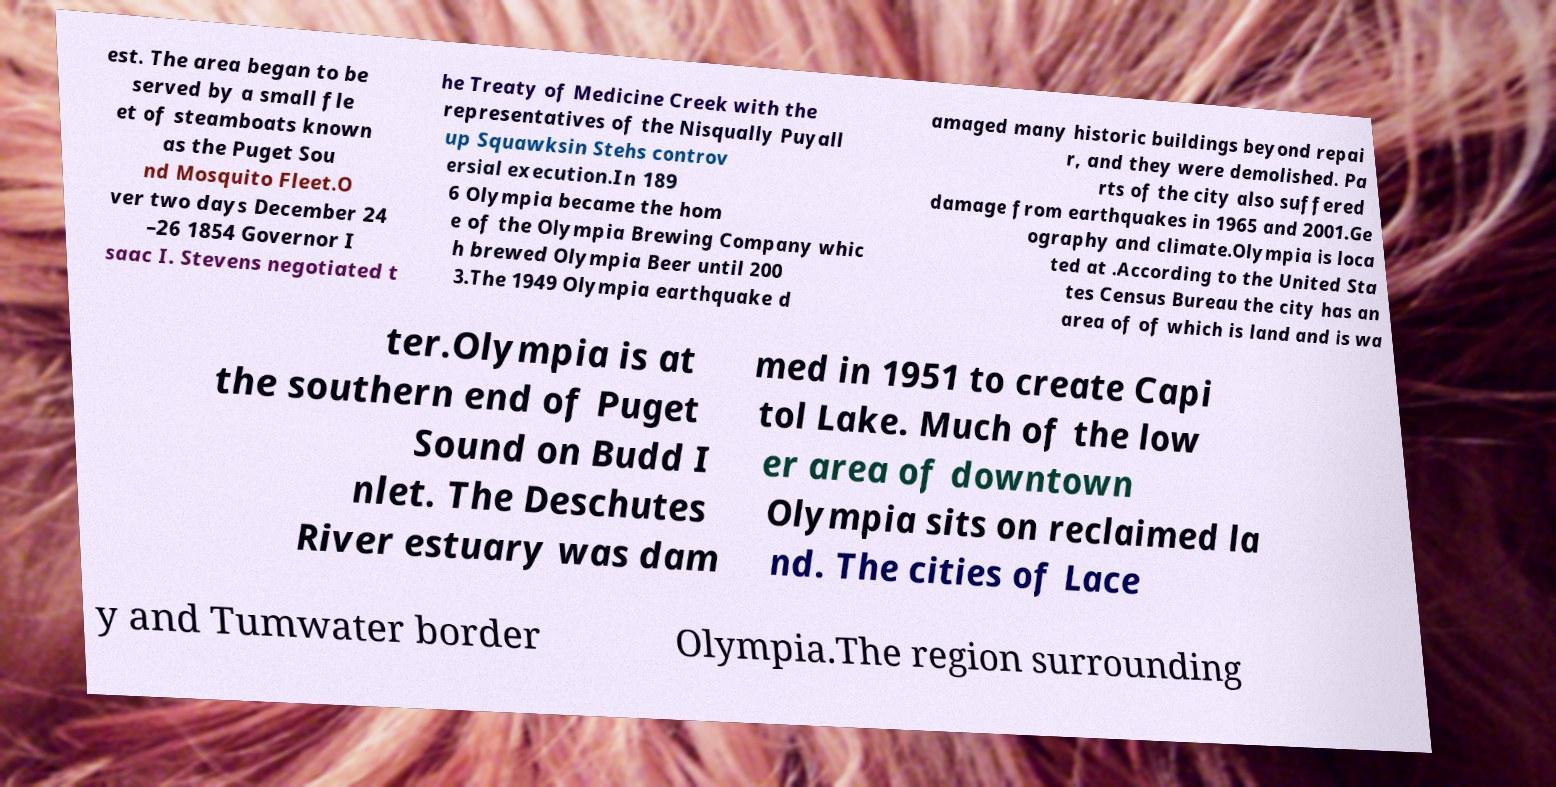Please read and relay the text visible in this image. What does it say? est. The area began to be served by a small fle et of steamboats known as the Puget Sou nd Mosquito Fleet.O ver two days December 24 –26 1854 Governor I saac I. Stevens negotiated t he Treaty of Medicine Creek with the representatives of the Nisqually Puyall up Squawksin Stehs controv ersial execution.In 189 6 Olympia became the hom e of the Olympia Brewing Company whic h brewed Olympia Beer until 200 3.The 1949 Olympia earthquake d amaged many historic buildings beyond repai r, and they were demolished. Pa rts of the city also suffered damage from earthquakes in 1965 and 2001.Ge ography and climate.Olympia is loca ted at .According to the United Sta tes Census Bureau the city has an area of of which is land and is wa ter.Olympia is at the southern end of Puget Sound on Budd I nlet. The Deschutes River estuary was dam med in 1951 to create Capi tol Lake. Much of the low er area of downtown Olympia sits on reclaimed la nd. The cities of Lace y and Tumwater border Olympia.The region surrounding 